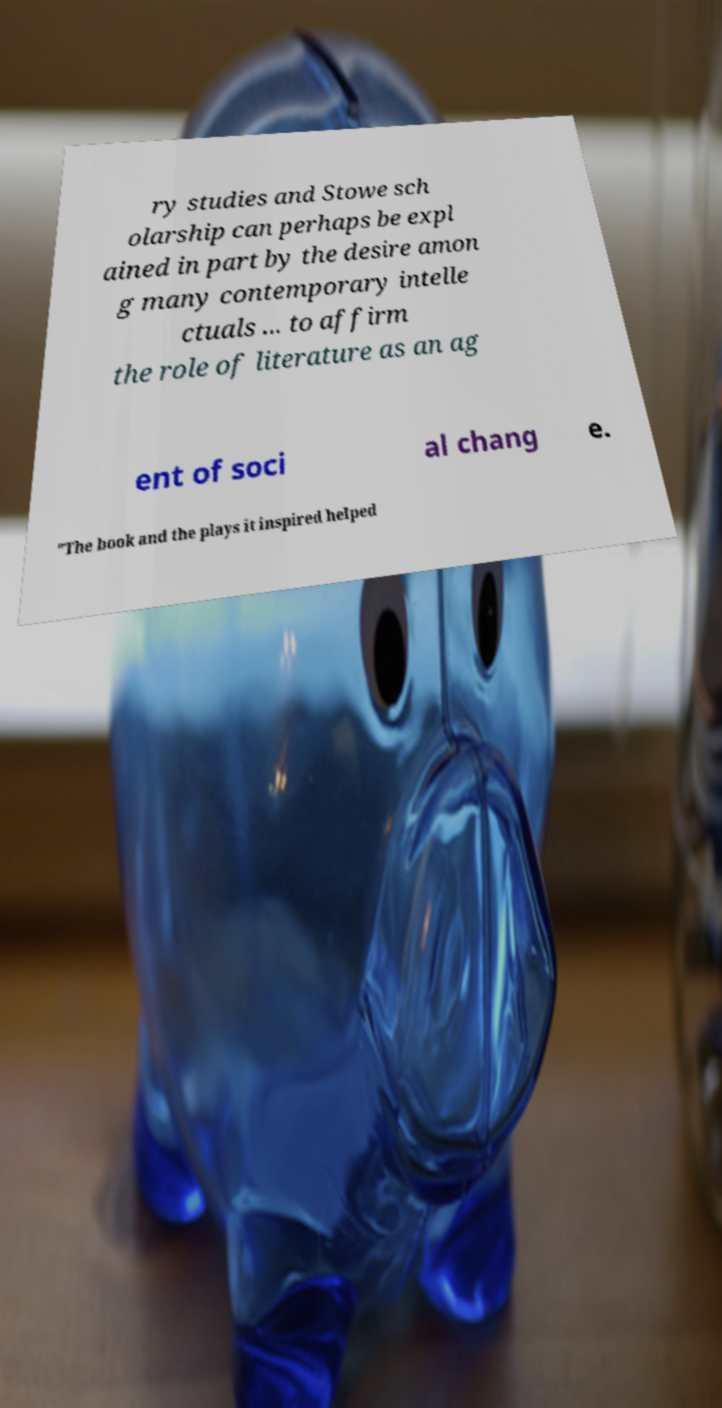For documentation purposes, I need the text within this image transcribed. Could you provide that? ry studies and Stowe sch olarship can perhaps be expl ained in part by the desire amon g many contemporary intelle ctuals ... to affirm the role of literature as an ag ent of soci al chang e. "The book and the plays it inspired helped 